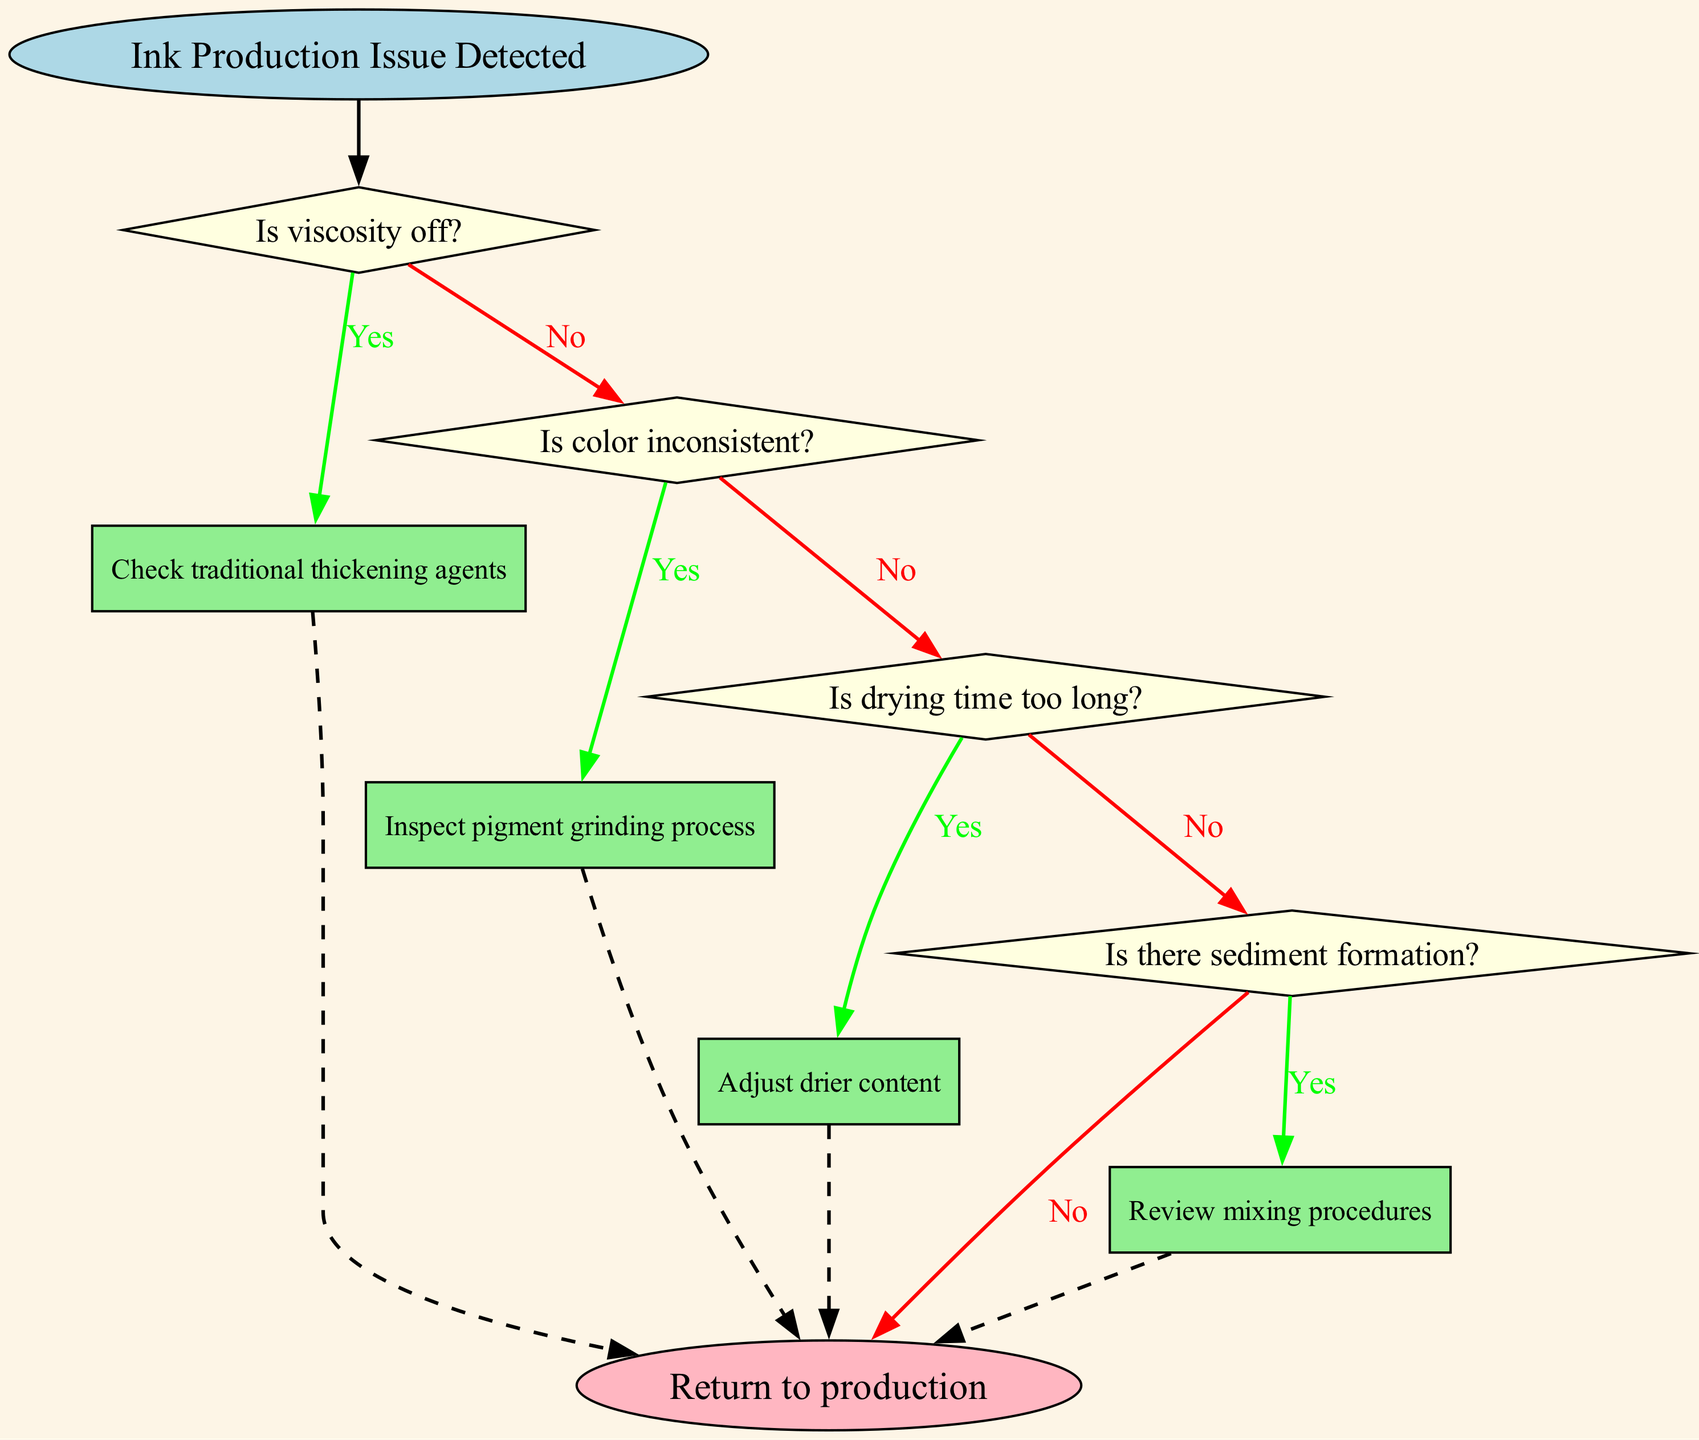What is the starting point of the flowchart? The starting point of the flowchart is labeled as "Ink Production Issue Detected," which indicates where the troubleshooting process begins.
Answer: Ink Production Issue Detected How many decision nodes are in the diagram? The diagram contains four decision nodes, each representing a question about common ink production issues.
Answer: 4 What happens if the viscosity is off? If the viscosity is off, the flowchart directs to "Check traditional thickening agents" as the next action to take in addressing the issue.
Answer: Check traditional thickening agents What action is taken if the drying time is too long? If the drying time is too long, the flowchart indicates that the next action is to "Adjust drier content" to resolve the issue.
Answer: Adjust drier content What is the final step if sediment formation is observed? If sediment formation is observed, the flowchart leads to "Review mixing procedures" as the final step before then returning to production.
Answer: Review mixing procedures If the color is inconsistent, what should be inspected? In the case of inconsistent color, the flowchart specifies to "Inspect pigment grinding process" to troubleshoot the problem further.
Answer: Inspect pigment grinding process What do you do if all checks return "No"? If all checks return "No," the flowchart advises to "Consult master formulator" to seek further expertise in resolving any ongoing issues.
Answer: Consult master formulator What is the color of the start node? The start node is filled with a light blue color, which differentiates it from other nodes in the diagram.
Answer: Light blue What does the dashed line from the action nodes signify? The dashed line from the action nodes signifies the flow returning to the end node, indicating the end of the troubleshooting process for that specific issue.
Answer: Return to production 